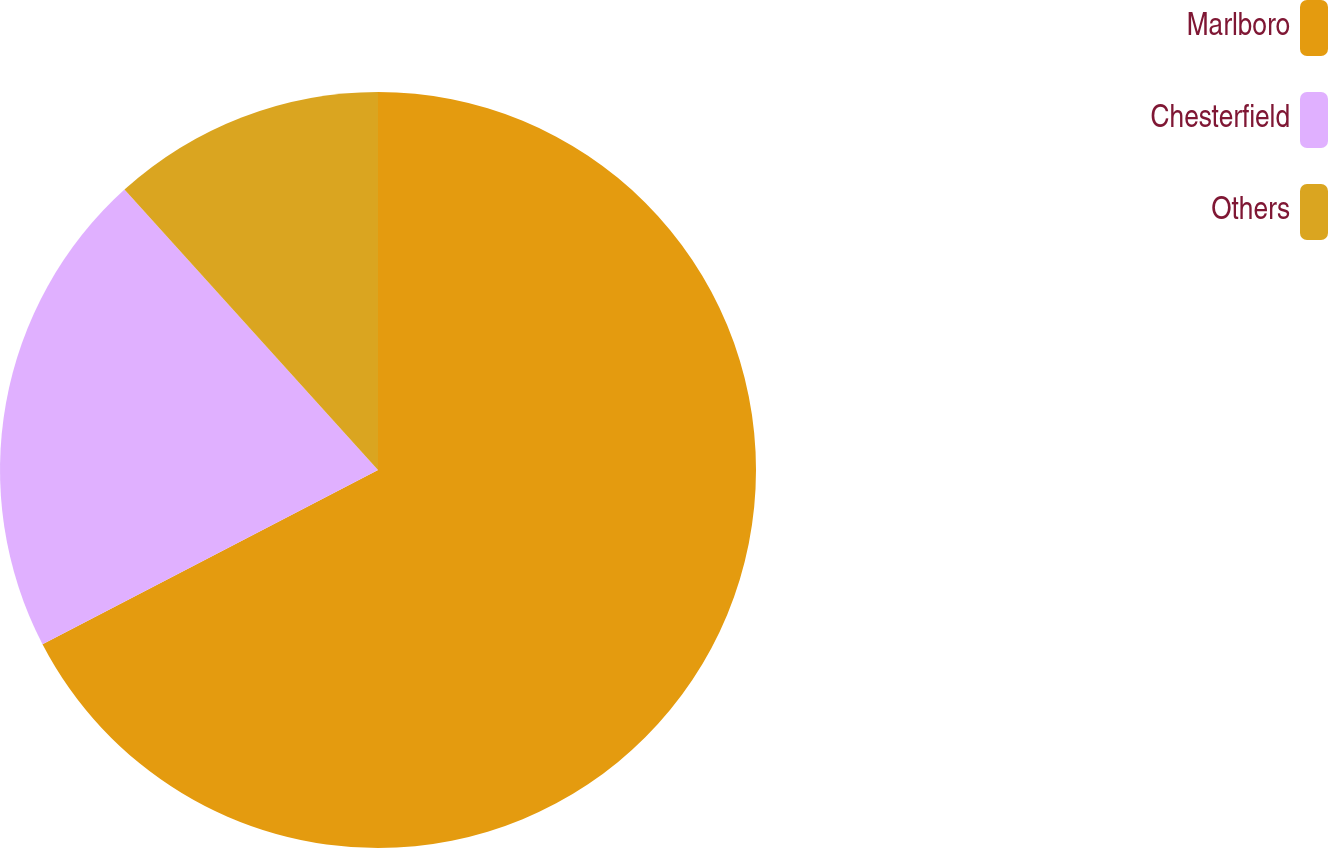<chart> <loc_0><loc_0><loc_500><loc_500><pie_chart><fcel>Marlboro<fcel>Chesterfield<fcel>Others<nl><fcel>67.38%<fcel>20.92%<fcel>11.7%<nl></chart> 